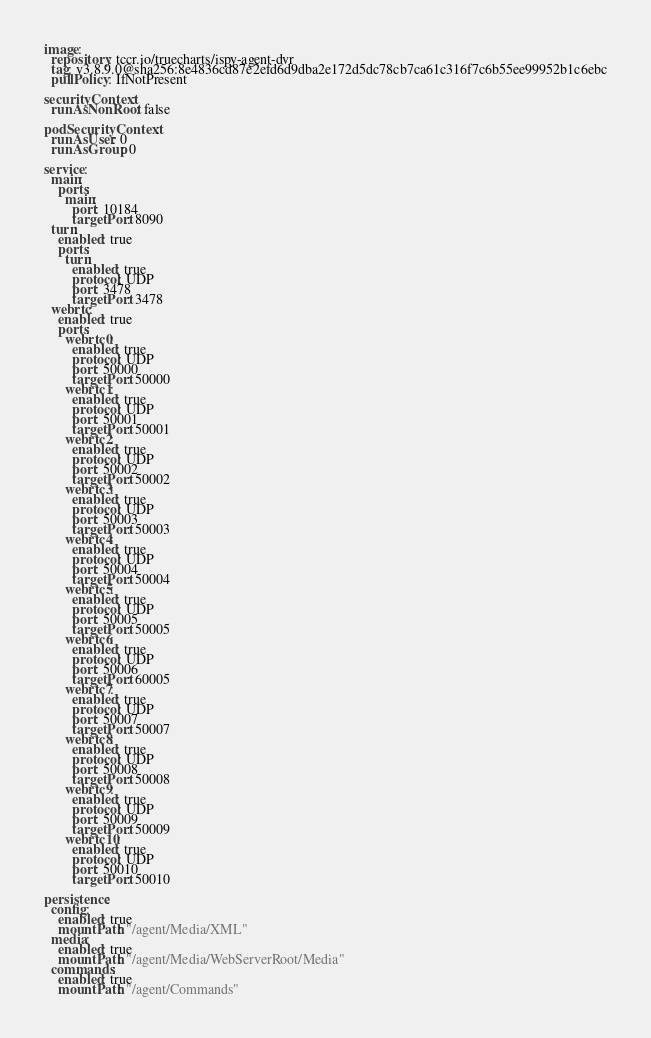Convert code to text. <code><loc_0><loc_0><loc_500><loc_500><_YAML_>image:
  repository: tccr.io/truecharts/ispy-agent-dvr
  tag: v3.8.9.0@sha256:8e4836cd87e2efd6d9dba2e172d5dc78cb7ca61c316f7c6b55ee99952b1c6ebc
  pullPolicy: IfNotPresent

securityContext:
  runAsNonRoot: false

podSecurityContext:
  runAsUser: 0
  runAsGroup: 0

service:
  main:
    ports:
      main:
        port: 10184
        targetPort: 8090
  turn:
    enabled: true
    ports:
      turn:
        enabled: true
        protocol: UDP
        port: 3478
        targetPort: 3478
  webrtc:
    enabled: true
    ports:
      webrtc0:
        enabled: true
        protocol: UDP
        port: 50000
        targetPort: 50000
      webrtc1:
        enabled: true
        protocol: UDP
        port: 50001
        targetPort: 50001
      webrtc2:
        enabled: true
        protocol: UDP
        port: 50002
        targetPort: 50002
      webrtc3:
        enabled: true
        protocol: UDP
        port: 50003
        targetPort: 50003
      webrtc4:
        enabled: true
        protocol: UDP
        port: 50004
        targetPort: 50004
      webrtc5:
        enabled: true
        protocol: UDP
        port: 50005
        targetPort: 50005
      webrtc6:
        enabled: true
        protocol: UDP
        port: 50006
        targetPort: 60005
      webrtc7:
        enabled: true
        protocol: UDP
        port: 50007
        targetPort: 50007
      webrtc8:
        enabled: true
        protocol: UDP
        port: 50008
        targetPort: 50008
      webrtc9:
        enabled: true
        protocol: UDP
        port: 50009
        targetPort: 50009
      webrtc10:
        enabled: true
        protocol: UDP
        port: 50010
        targetPort: 50010

persistence:
  config:
    enabled: true
    mountPath: "/agent/Media/XML"
  media:
    enabled: true
    mountPath: "/agent/Media/WebServerRoot/Media"
  commands:
    enabled: true
    mountPath: "/agent/Commands"
</code> 